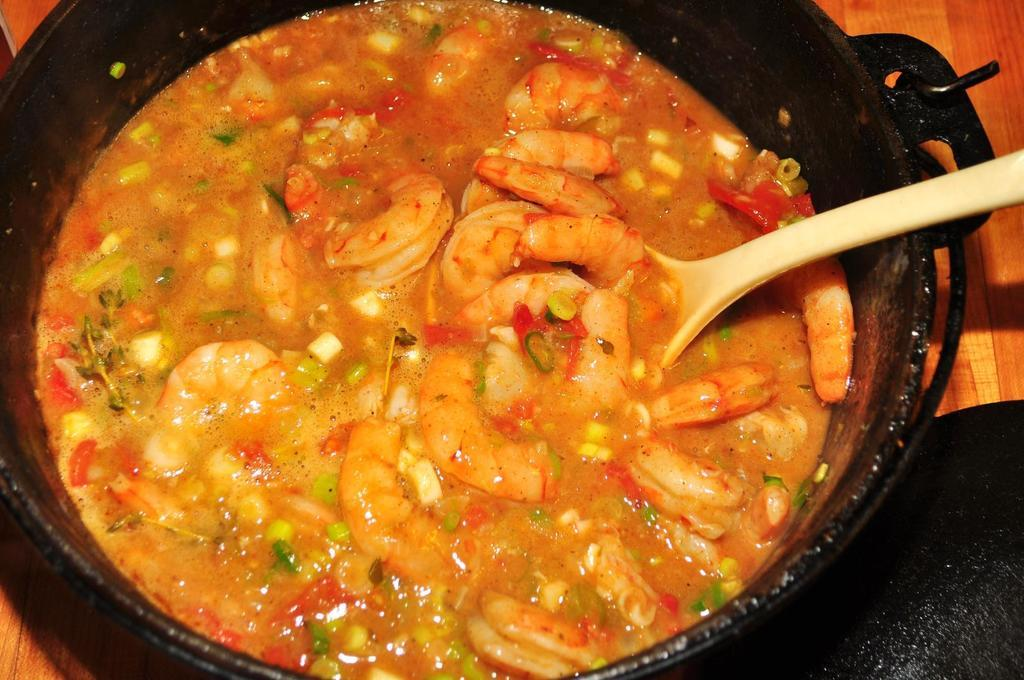What color is the bowl in the image? The bowl in the image is black. What is inside the bowl? The bowl contains a curry-like substance. What color is the spoon in the image? The spoon in the image is white. Who is the creator of the night depicted in the image? There is no depiction of a night or any creator in the image; it features a black bowl with a curry-like substance and a white spoon. 